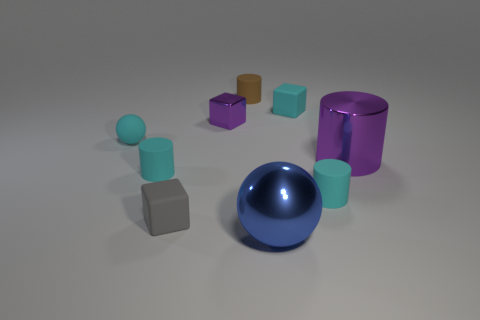What is the arrangement of objects in the image? The objects are arranged in a scattered formation, with no apparent pattern. They seem to be placed at varying distances from one another, occupying the foreground and middle ground primarily. 